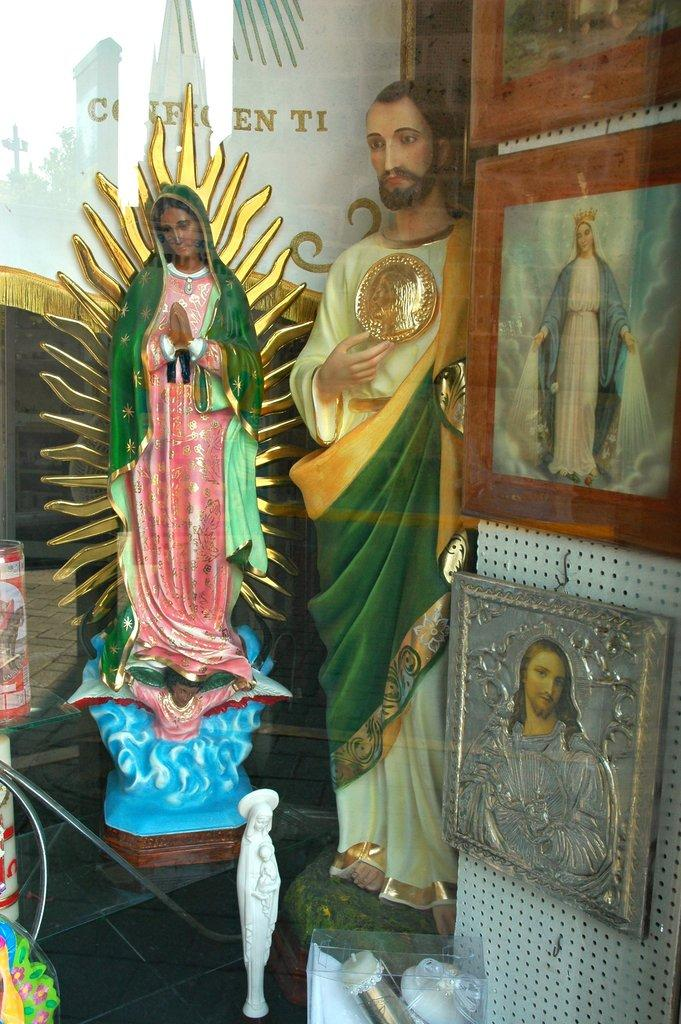What type of sculptures can be seen in the image? There are sculptures of Jesus in the image. What else is present on the wall in the image? There are photo frames on the wall in the image. What type of credit can be seen in the image? There is no credit present in the image; it is a picture of sculptures and photo frames. What time of day is depicted in the image? The time of day cannot be determined from the image, as there are no indications of morning or any other time. 